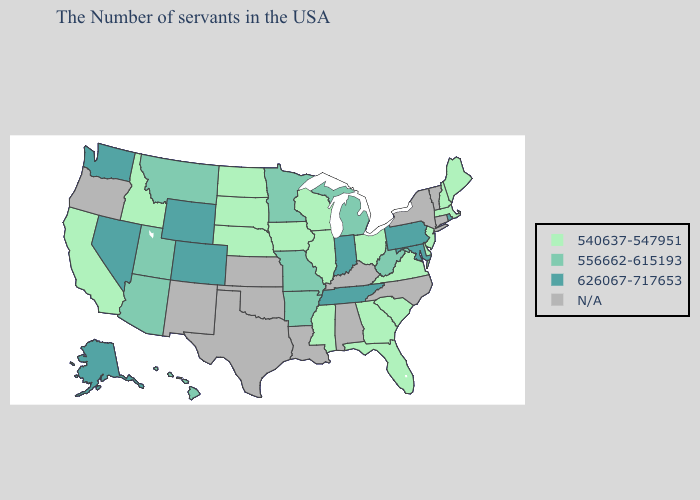What is the lowest value in the South?
Write a very short answer. 540637-547951. Among the states that border South Dakota , does Wyoming have the lowest value?
Short answer required. No. Name the states that have a value in the range N/A?
Concise answer only. Vermont, Connecticut, New York, North Carolina, Kentucky, Alabama, Louisiana, Kansas, Oklahoma, Texas, New Mexico, Oregon. Does North Dakota have the highest value in the MidWest?
Write a very short answer. No. Name the states that have a value in the range N/A?
Short answer required. Vermont, Connecticut, New York, North Carolina, Kentucky, Alabama, Louisiana, Kansas, Oklahoma, Texas, New Mexico, Oregon. Name the states that have a value in the range 556662-615193?
Be succinct. West Virginia, Michigan, Missouri, Arkansas, Minnesota, Utah, Montana, Arizona, Hawaii. What is the value of Nevada?
Keep it brief. 626067-717653. Among the states that border Maryland , which have the lowest value?
Write a very short answer. Delaware, Virginia. Name the states that have a value in the range N/A?
Short answer required. Vermont, Connecticut, New York, North Carolina, Kentucky, Alabama, Louisiana, Kansas, Oklahoma, Texas, New Mexico, Oregon. Does Tennessee have the highest value in the South?
Be succinct. Yes. Is the legend a continuous bar?
Be succinct. No. Name the states that have a value in the range N/A?
Give a very brief answer. Vermont, Connecticut, New York, North Carolina, Kentucky, Alabama, Louisiana, Kansas, Oklahoma, Texas, New Mexico, Oregon. 